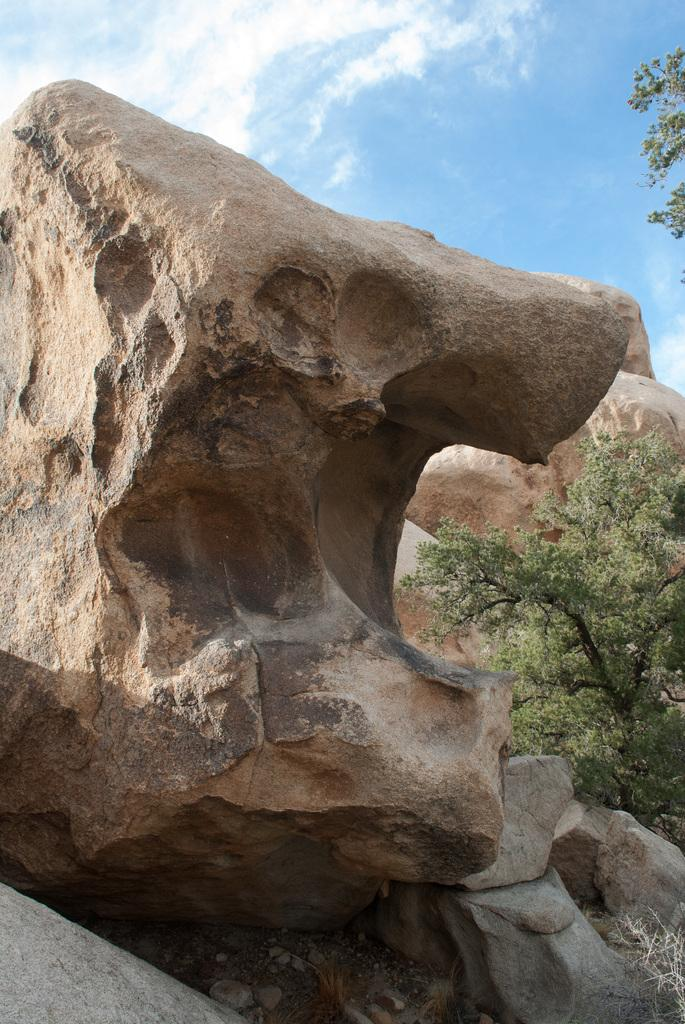What type of natural elements can be seen in the image? There are rocks and trees in the image. What is visible in the background of the image? The sky is visible in the background of the image. Can you see a rabbit playing basketball in the image? There is no rabbit or basketball present in the image. 